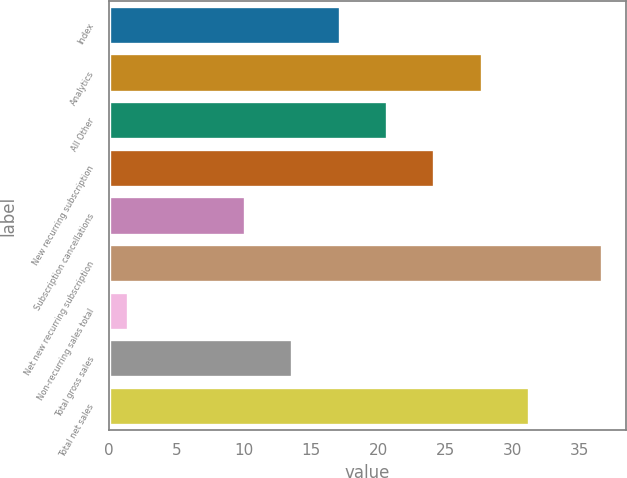Convert chart. <chart><loc_0><loc_0><loc_500><loc_500><bar_chart><fcel>Index<fcel>Analytics<fcel>All Other<fcel>New recurring subscription<fcel>Subscription cancellations<fcel>Net new recurring subscription<fcel>Non-recurring sales total<fcel>Total gross sales<fcel>Total net sales<nl><fcel>17.14<fcel>27.7<fcel>20.66<fcel>24.18<fcel>10.1<fcel>36.6<fcel>1.4<fcel>13.62<fcel>31.22<nl></chart> 